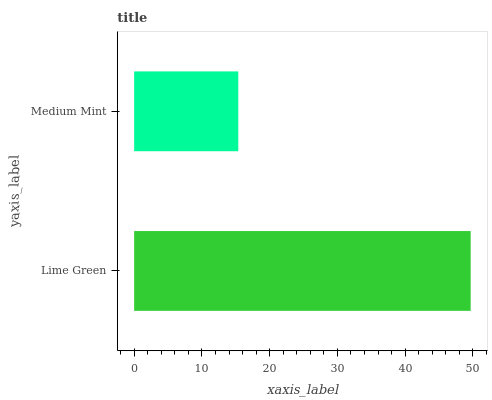Is Medium Mint the minimum?
Answer yes or no. Yes. Is Lime Green the maximum?
Answer yes or no. Yes. Is Medium Mint the maximum?
Answer yes or no. No. Is Lime Green greater than Medium Mint?
Answer yes or no. Yes. Is Medium Mint less than Lime Green?
Answer yes or no. Yes. Is Medium Mint greater than Lime Green?
Answer yes or no. No. Is Lime Green less than Medium Mint?
Answer yes or no. No. Is Lime Green the high median?
Answer yes or no. Yes. Is Medium Mint the low median?
Answer yes or no. Yes. Is Medium Mint the high median?
Answer yes or no. No. Is Lime Green the low median?
Answer yes or no. No. 